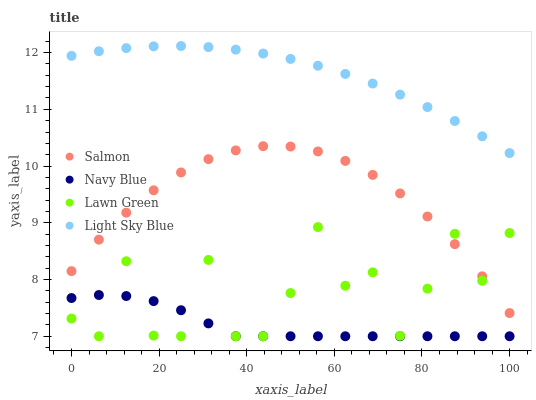Does Navy Blue have the minimum area under the curve?
Answer yes or no. Yes. Does Light Sky Blue have the maximum area under the curve?
Answer yes or no. Yes. Does Salmon have the minimum area under the curve?
Answer yes or no. No. Does Salmon have the maximum area under the curve?
Answer yes or no. No. Is Light Sky Blue the smoothest?
Answer yes or no. Yes. Is Lawn Green the roughest?
Answer yes or no. Yes. Is Salmon the smoothest?
Answer yes or no. No. Is Salmon the roughest?
Answer yes or no. No. Does Navy Blue have the lowest value?
Answer yes or no. Yes. Does Salmon have the lowest value?
Answer yes or no. No. Does Light Sky Blue have the highest value?
Answer yes or no. Yes. Does Salmon have the highest value?
Answer yes or no. No. Is Navy Blue less than Salmon?
Answer yes or no. Yes. Is Light Sky Blue greater than Navy Blue?
Answer yes or no. Yes. Does Navy Blue intersect Lawn Green?
Answer yes or no. Yes. Is Navy Blue less than Lawn Green?
Answer yes or no. No. Is Navy Blue greater than Lawn Green?
Answer yes or no. No. Does Navy Blue intersect Salmon?
Answer yes or no. No. 